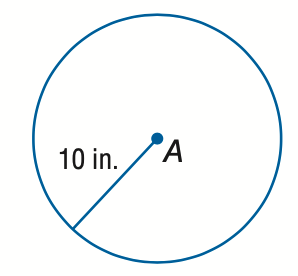Answer the mathemtical geometry problem and directly provide the correct option letter.
Question: Find the circumference of \odot A.
Choices: A: 10 \pi B: 20 \pi C: 50 \pi D: 100 \pi B 